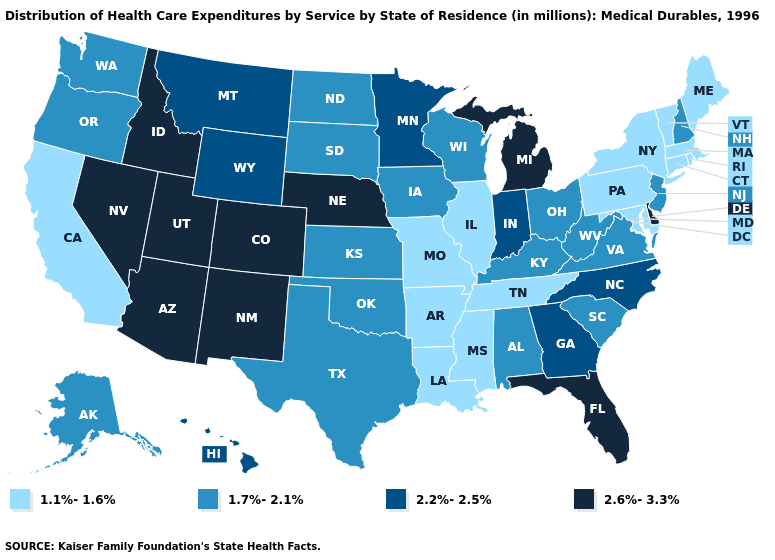Is the legend a continuous bar?
Keep it brief. No. Does the map have missing data?
Be succinct. No. Name the states that have a value in the range 2.6%-3.3%?
Quick response, please. Arizona, Colorado, Delaware, Florida, Idaho, Michigan, Nebraska, Nevada, New Mexico, Utah. What is the value of New Hampshire?
Concise answer only. 1.7%-2.1%. Name the states that have a value in the range 2.6%-3.3%?
Quick response, please. Arizona, Colorado, Delaware, Florida, Idaho, Michigan, Nebraska, Nevada, New Mexico, Utah. Which states hav the highest value in the West?
Write a very short answer. Arizona, Colorado, Idaho, Nevada, New Mexico, Utah. Does Connecticut have the lowest value in the USA?
Answer briefly. Yes. What is the value of Utah?
Keep it brief. 2.6%-3.3%. Does New Hampshire have the highest value in the USA?
Write a very short answer. No. Name the states that have a value in the range 1.1%-1.6%?
Short answer required. Arkansas, California, Connecticut, Illinois, Louisiana, Maine, Maryland, Massachusetts, Mississippi, Missouri, New York, Pennsylvania, Rhode Island, Tennessee, Vermont. Which states have the lowest value in the USA?
Give a very brief answer. Arkansas, California, Connecticut, Illinois, Louisiana, Maine, Maryland, Massachusetts, Mississippi, Missouri, New York, Pennsylvania, Rhode Island, Tennessee, Vermont. What is the value of Montana?
Concise answer only. 2.2%-2.5%. Does Arkansas have the lowest value in the South?
Keep it brief. Yes. What is the value of Nevada?
Concise answer only. 2.6%-3.3%. 